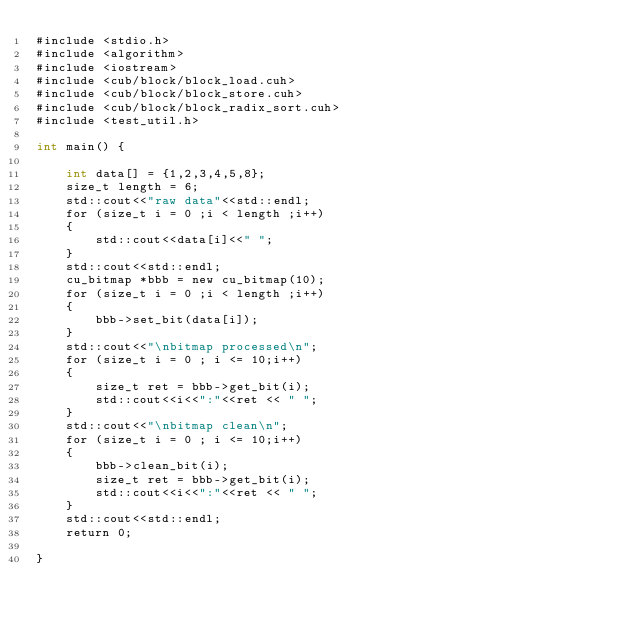Convert code to text. <code><loc_0><loc_0><loc_500><loc_500><_Cuda_>#include <stdio.h>
#include <algorithm>
#include <iostream>
#include <cub/block/block_load.cuh>
#include <cub/block/block_store.cuh>
#include <cub/block/block_radix_sort.cuh>
#include <test_util.h>

int main() {

    int data[] = {1,2,3,4,5,8};
    size_t length = 6;
    std::cout<<"raw data"<<std::endl;
    for (size_t i = 0 ;i < length ;i++)
    {
        std::cout<<data[i]<<" ";
    }
    std::cout<<std::endl;
    cu_bitmap *bbb = new cu_bitmap(10);
    for (size_t i = 0 ;i < length ;i++)
    {
        bbb->set_bit(data[i]);
    }
    std::cout<<"\nbitmap processed\n";
    for (size_t i = 0 ; i <= 10;i++)
    {
        size_t ret = bbb->get_bit(i);
        std::cout<<i<<":"<<ret << " ";
    }
    std::cout<<"\nbitmap clean\n";
    for (size_t i = 0 ; i <= 10;i++)
    {
        bbb->clean_bit(i);
        size_t ret = bbb->get_bit(i);
        std::cout<<i<<":"<<ret << " ";
    }
    std::cout<<std::endl;
    return 0;

}
</code> 